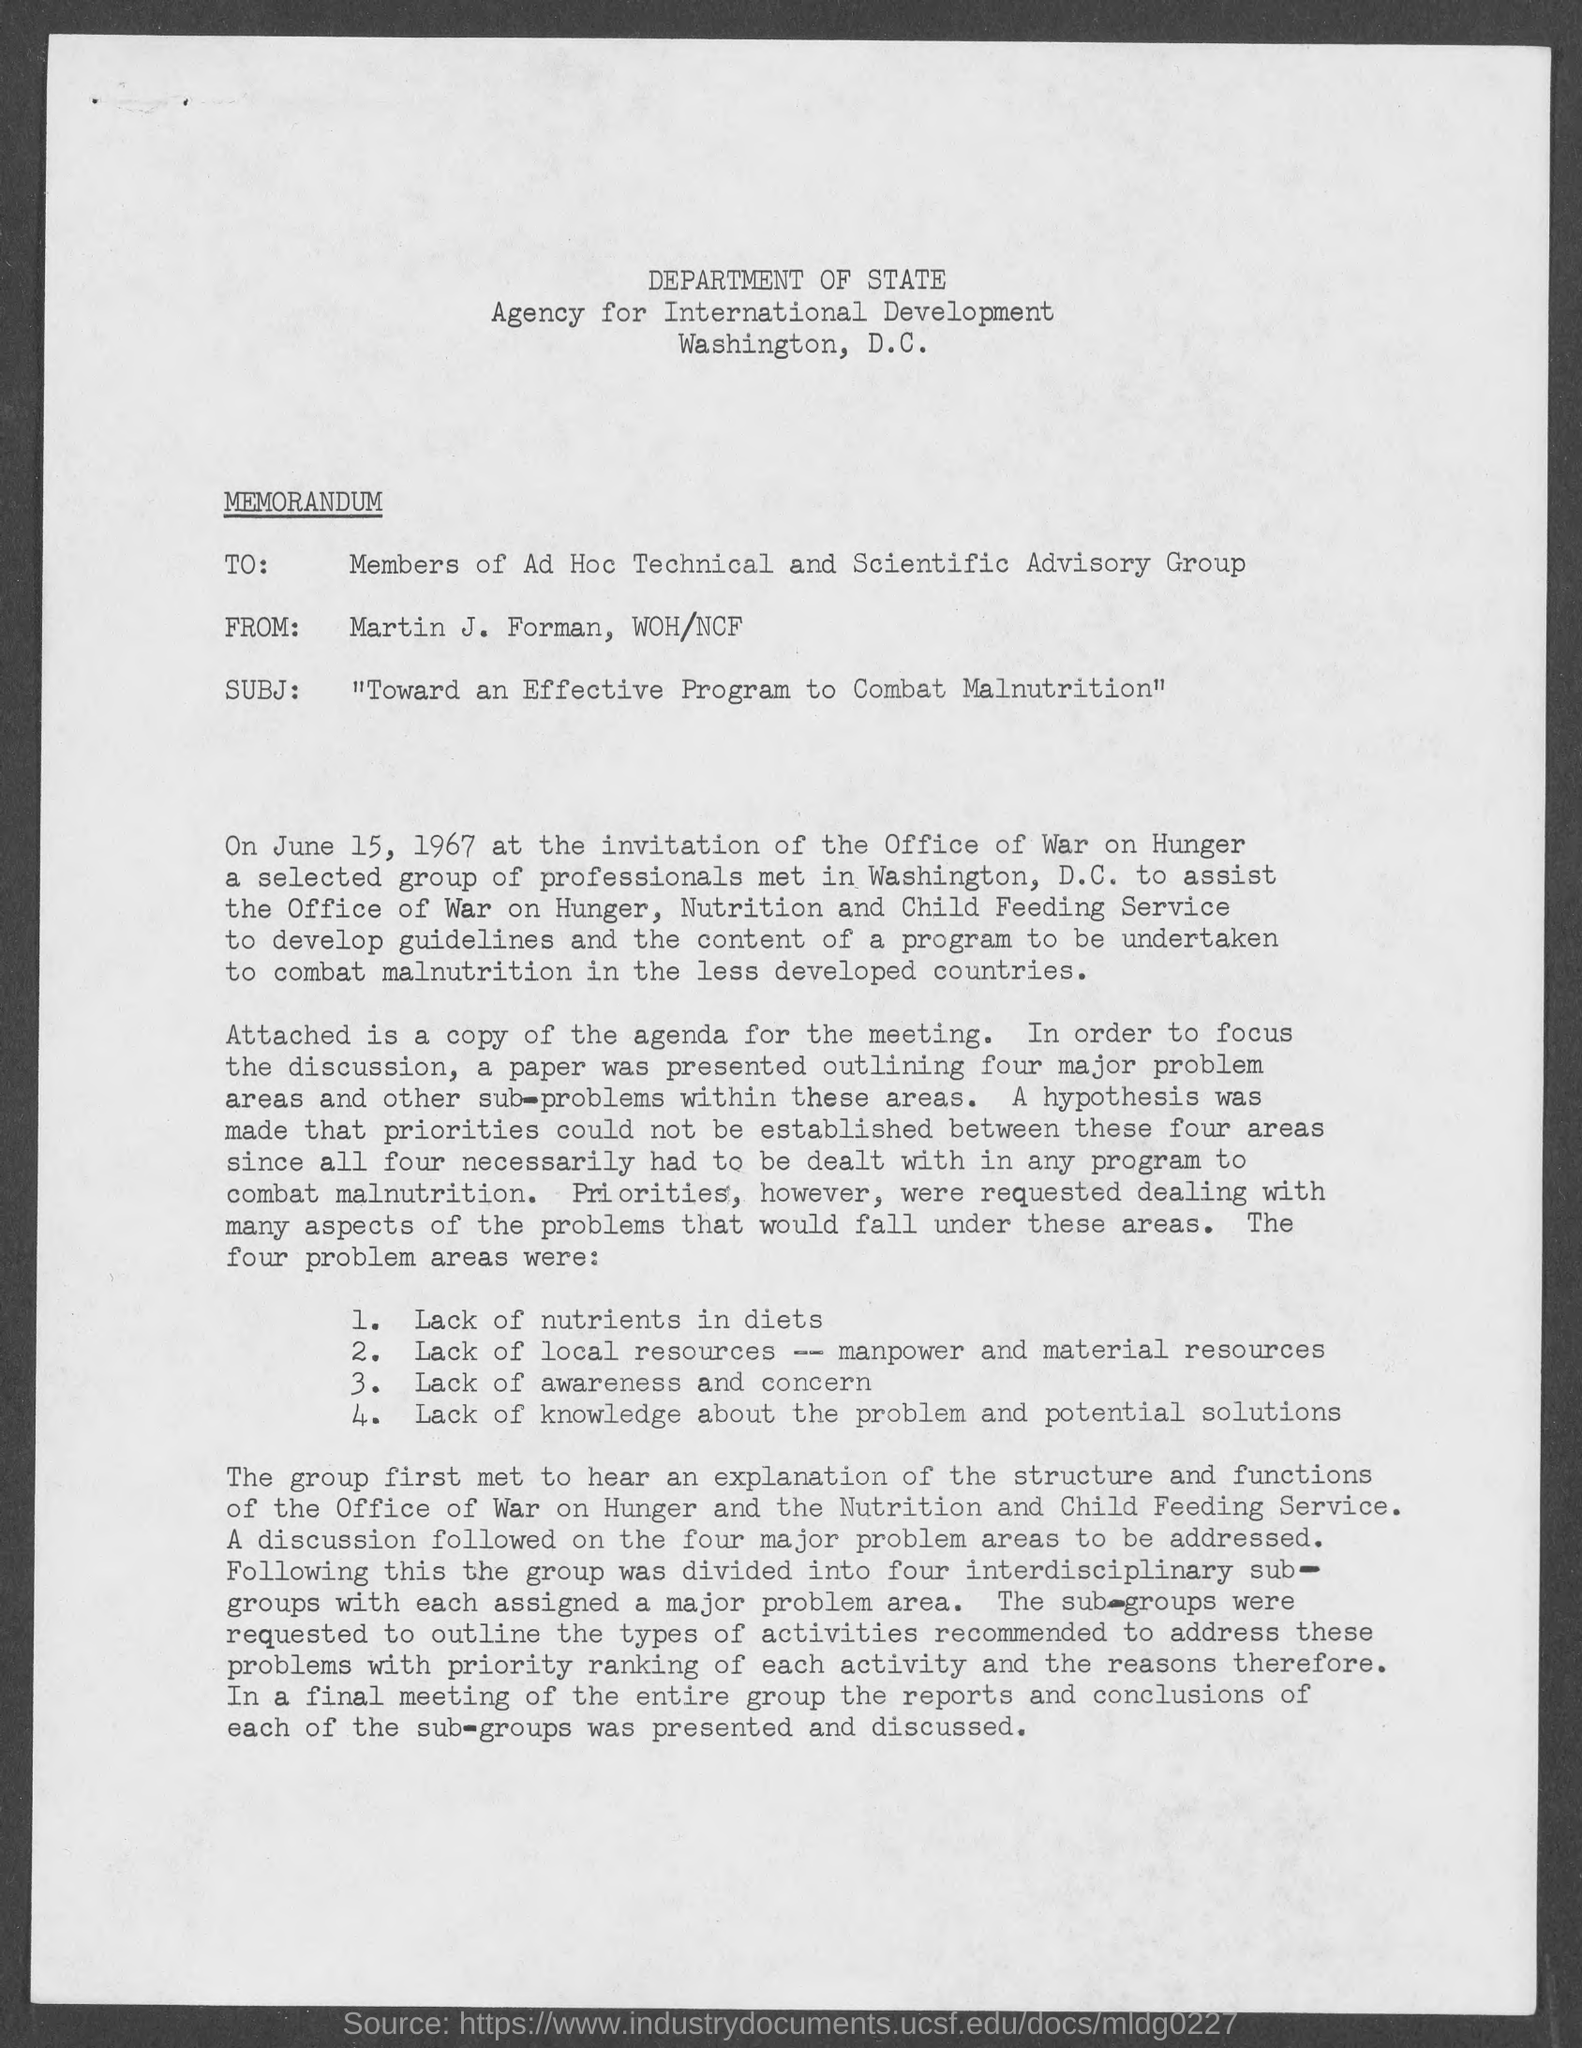What kind of communication is this ?
Keep it short and to the point. MEMORANDUM. Who is the sender of this memorandum?
Keep it short and to the point. Martin j. forman. Who is the receiver of this memorandum?
Provide a succinct answer. Members of ad hoc technical and scientific advisory group. Which department is mentioned in the header of the document?
Keep it short and to the point. Department of state. 